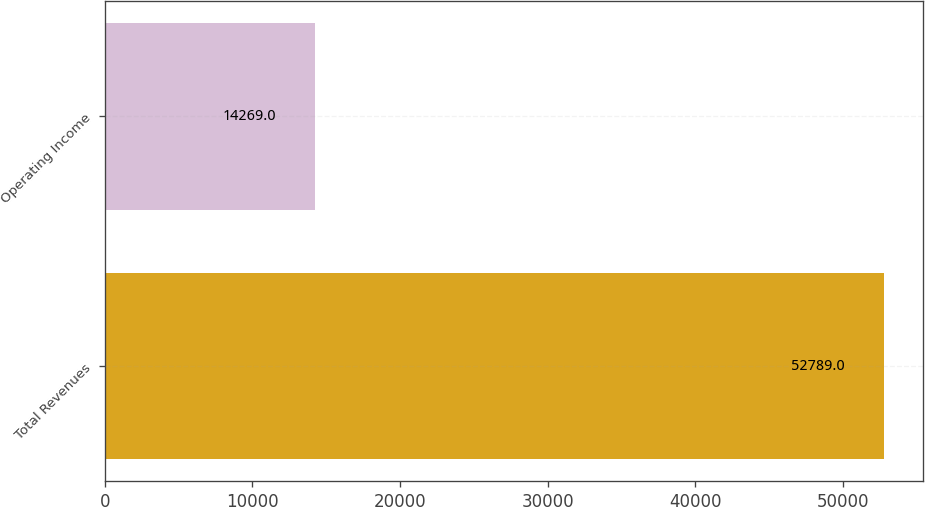<chart> <loc_0><loc_0><loc_500><loc_500><bar_chart><fcel>Total Revenues<fcel>Operating Income<nl><fcel>52789<fcel>14269<nl></chart> 